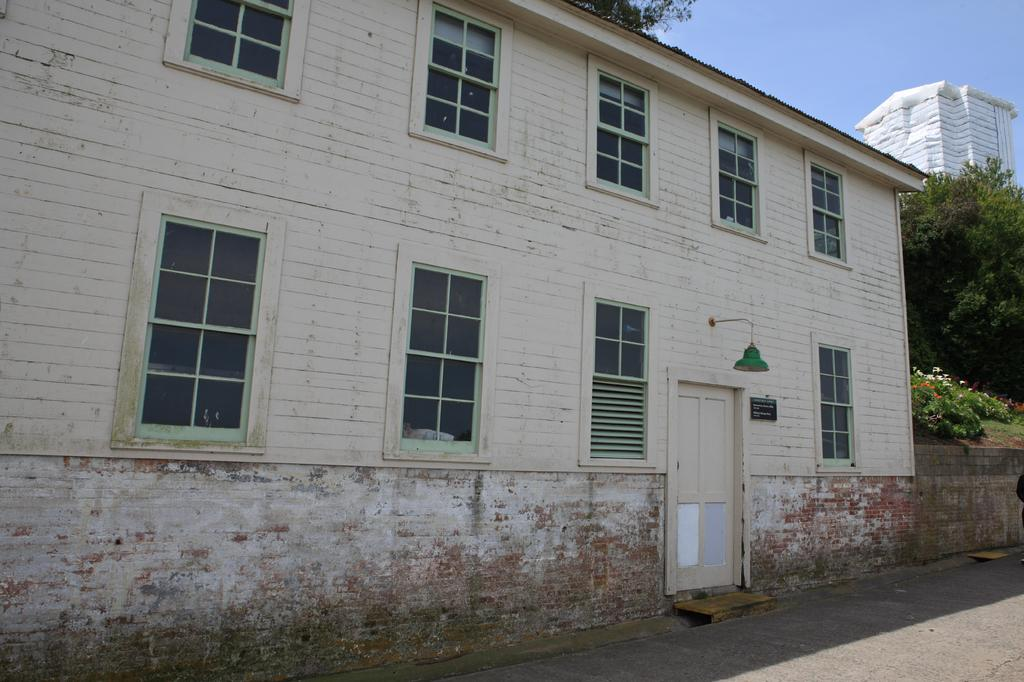What type of structure is visible in the image? There is a building in the image. What else can be seen in the image besides the building? There is a road, flowers, trees, and the sky visible in the image. Can you describe the background of the image? The background of the image includes another building and the sky. How does the visitor interact with the flowers in the image? There is no visitor present in the image, so it is not possible to determine how they might interact with the flowers. 